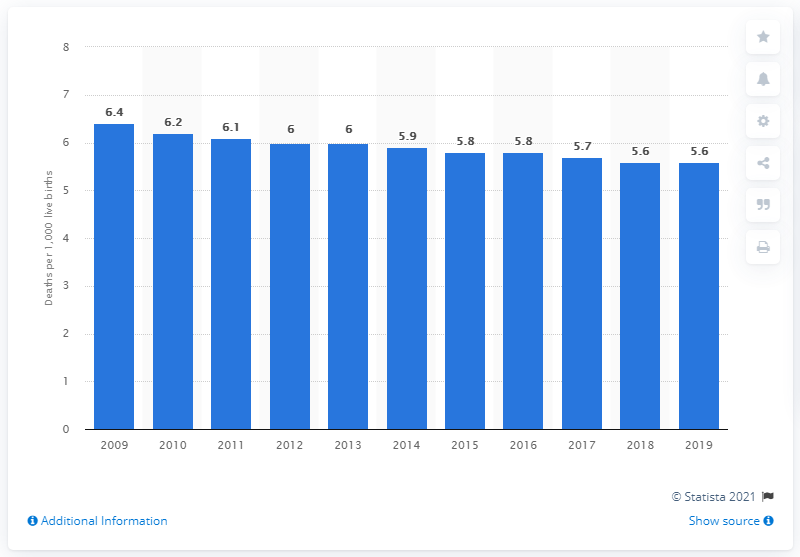Identify some key points in this picture. In 2019, the infant mortality rate in the United States was 5.6 deaths per 1,000 live births. 